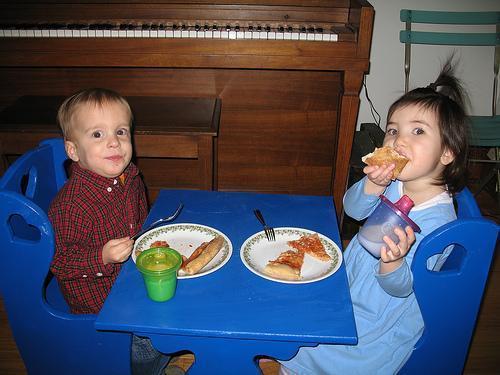How many children are seated?
Give a very brief answer. 2. How many children are in the photo?
Give a very brief answer. 2. 